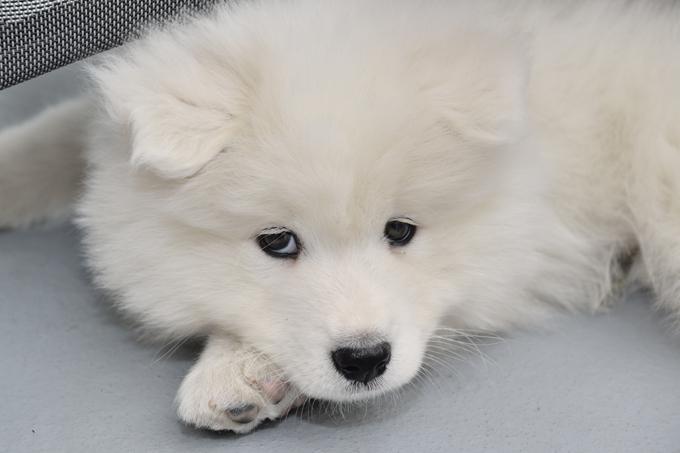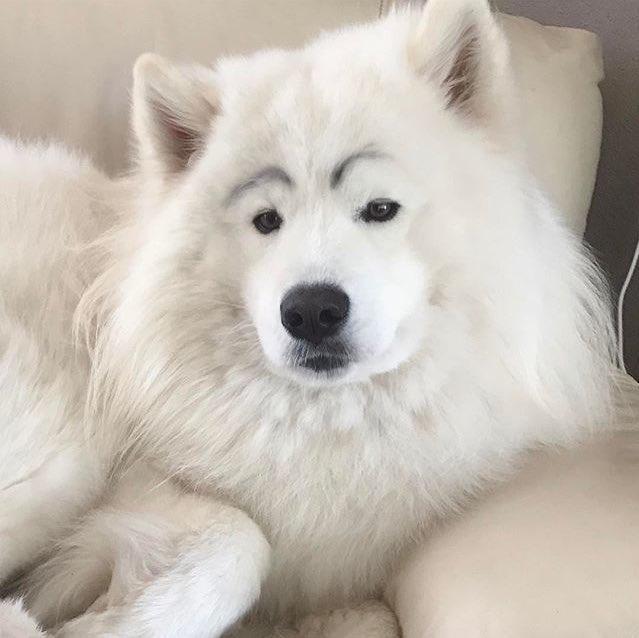The first image is the image on the left, the second image is the image on the right. Assess this claim about the two images: "All four dogs are white.". Correct or not? Answer yes or no. No. The first image is the image on the left, the second image is the image on the right. For the images shown, is this caption "One image shows three same-sized white puppies posed side-by-side." true? Answer yes or no. No. 